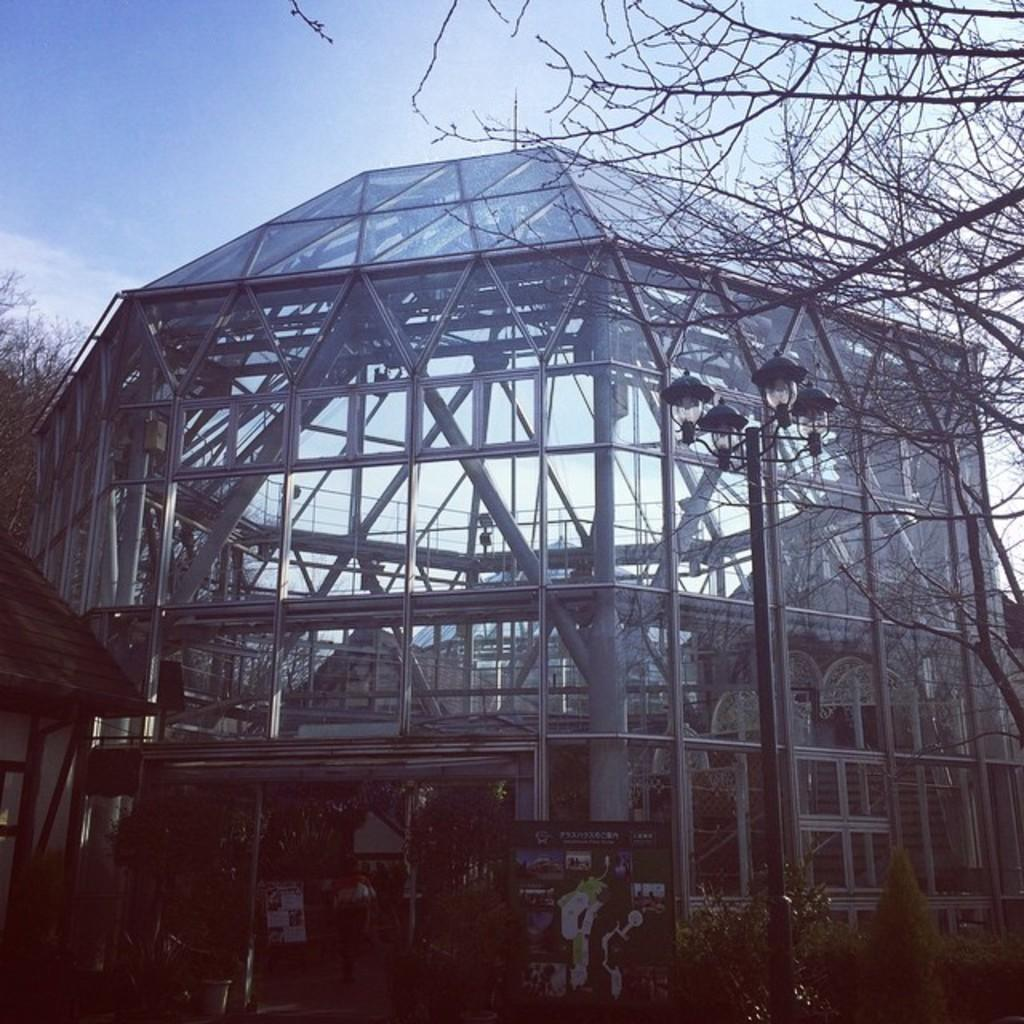What type of building is in the image? There is a glass building in the image. What is located in front of the building? There is a light pole in front of the building. What is attached to the light pole? There are boards attached to the light pole. What type of vegetation can be seen in the image? There are dried trees in the image. What is the color of the sky in the image? The sky is visible in the image, with a combination of white and blue colors. What type of cherry is growing on the dried trees in the image? There are no cherries present in the image, as the trees are dried. 